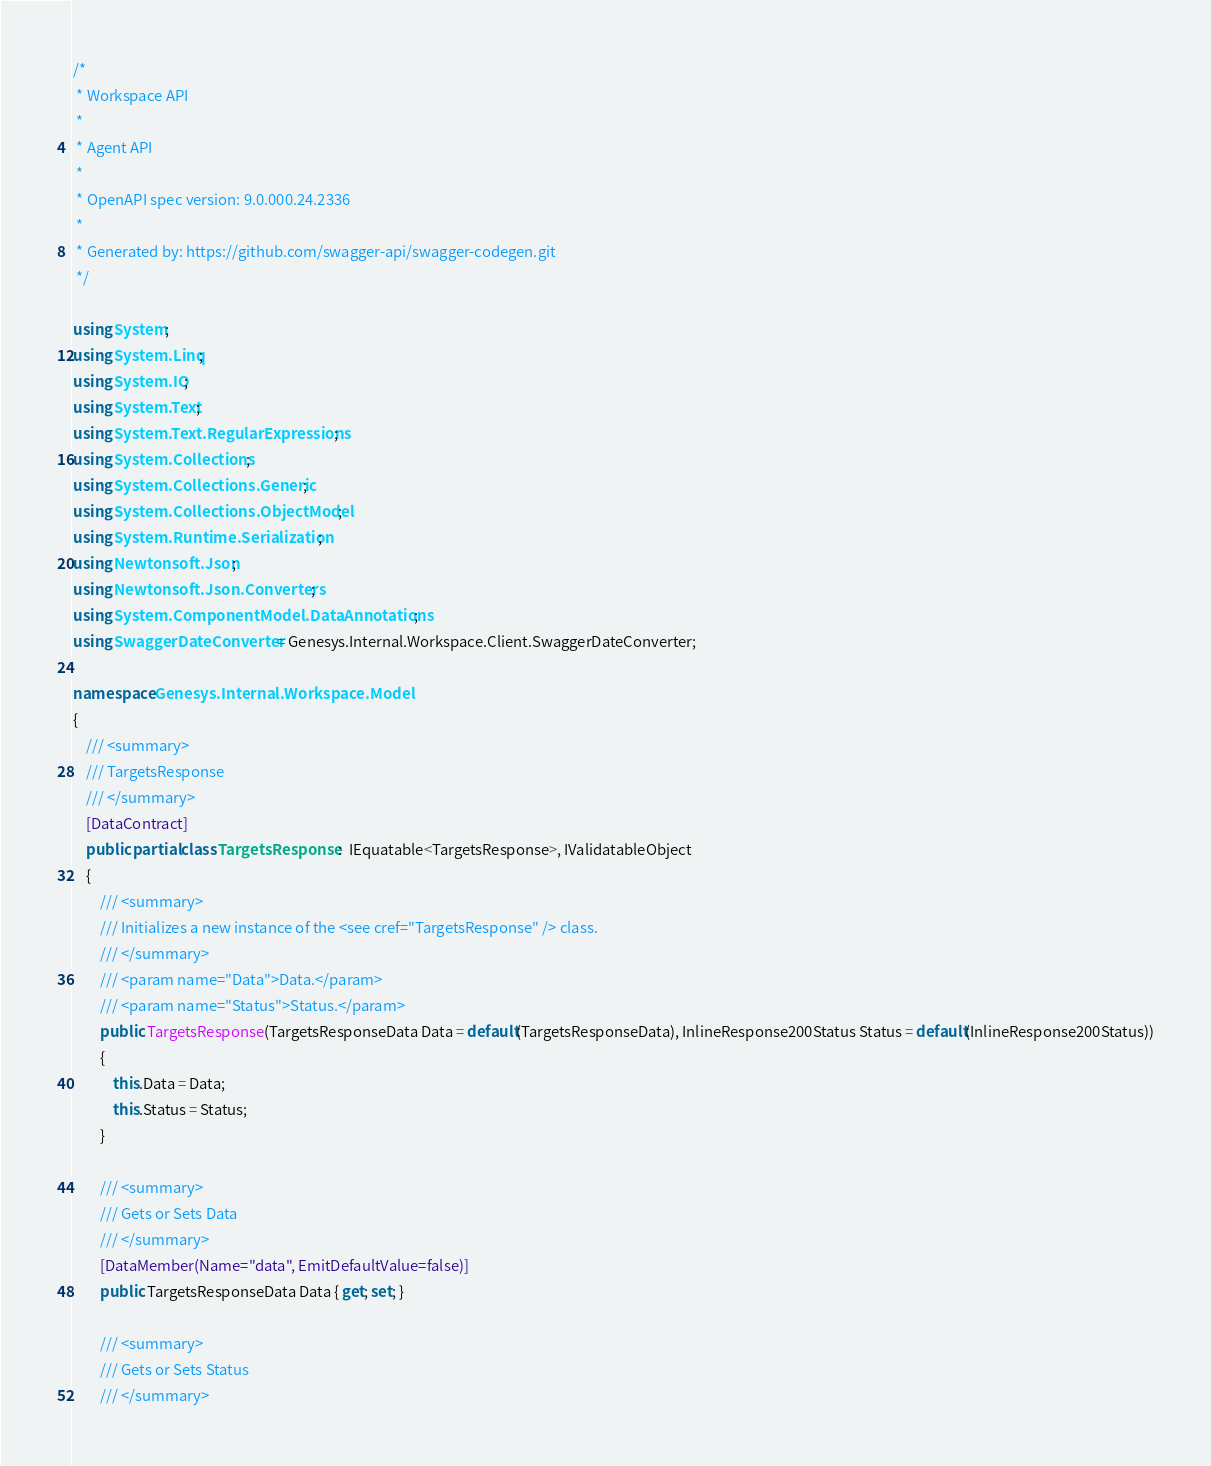<code> <loc_0><loc_0><loc_500><loc_500><_C#_>/* 
 * Workspace API
 *
 * Agent API
 *
 * OpenAPI spec version: 9.0.000.24.2336
 * 
 * Generated by: https://github.com/swagger-api/swagger-codegen.git
 */

using System;
using System.Linq;
using System.IO;
using System.Text;
using System.Text.RegularExpressions;
using System.Collections;
using System.Collections.Generic;
using System.Collections.ObjectModel;
using System.Runtime.Serialization;
using Newtonsoft.Json;
using Newtonsoft.Json.Converters;
using System.ComponentModel.DataAnnotations;
using SwaggerDateConverter = Genesys.Internal.Workspace.Client.SwaggerDateConverter;

namespace Genesys.Internal.Workspace.Model
{
    /// <summary>
    /// TargetsResponse
    /// </summary>
    [DataContract]
    public partial class TargetsResponse :  IEquatable<TargetsResponse>, IValidatableObject
    {
        /// <summary>
        /// Initializes a new instance of the <see cref="TargetsResponse" /> class.
        /// </summary>
        /// <param name="Data">Data.</param>
        /// <param name="Status">Status.</param>
        public TargetsResponse(TargetsResponseData Data = default(TargetsResponseData), InlineResponse200Status Status = default(InlineResponse200Status))
        {
            this.Data = Data;
            this.Status = Status;
        }
        
        /// <summary>
        /// Gets or Sets Data
        /// </summary>
        [DataMember(Name="data", EmitDefaultValue=false)]
        public TargetsResponseData Data { get; set; }

        /// <summary>
        /// Gets or Sets Status
        /// </summary></code> 